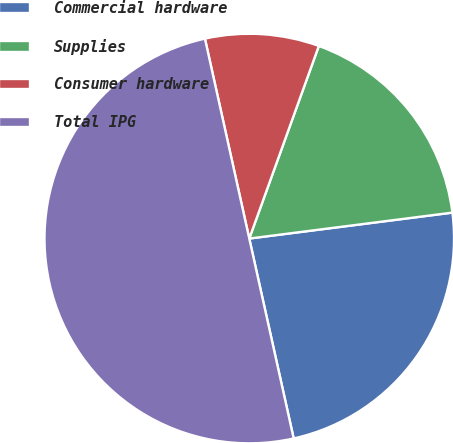<chart> <loc_0><loc_0><loc_500><loc_500><pie_chart><fcel>Commercial hardware<fcel>Supplies<fcel>Consumer hardware<fcel>Total IPG<nl><fcel>23.54%<fcel>17.46%<fcel>8.99%<fcel>50.0%<nl></chart> 